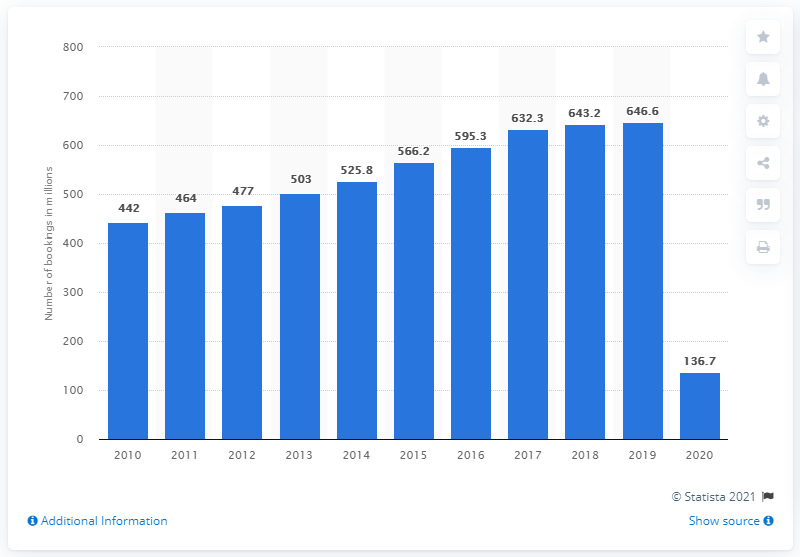Mention a couple of crucial points in this snapshot. In 2020, a total of 136,700 bookings were made using the Amadeus global distribution system, including both air and non-air bookings. 